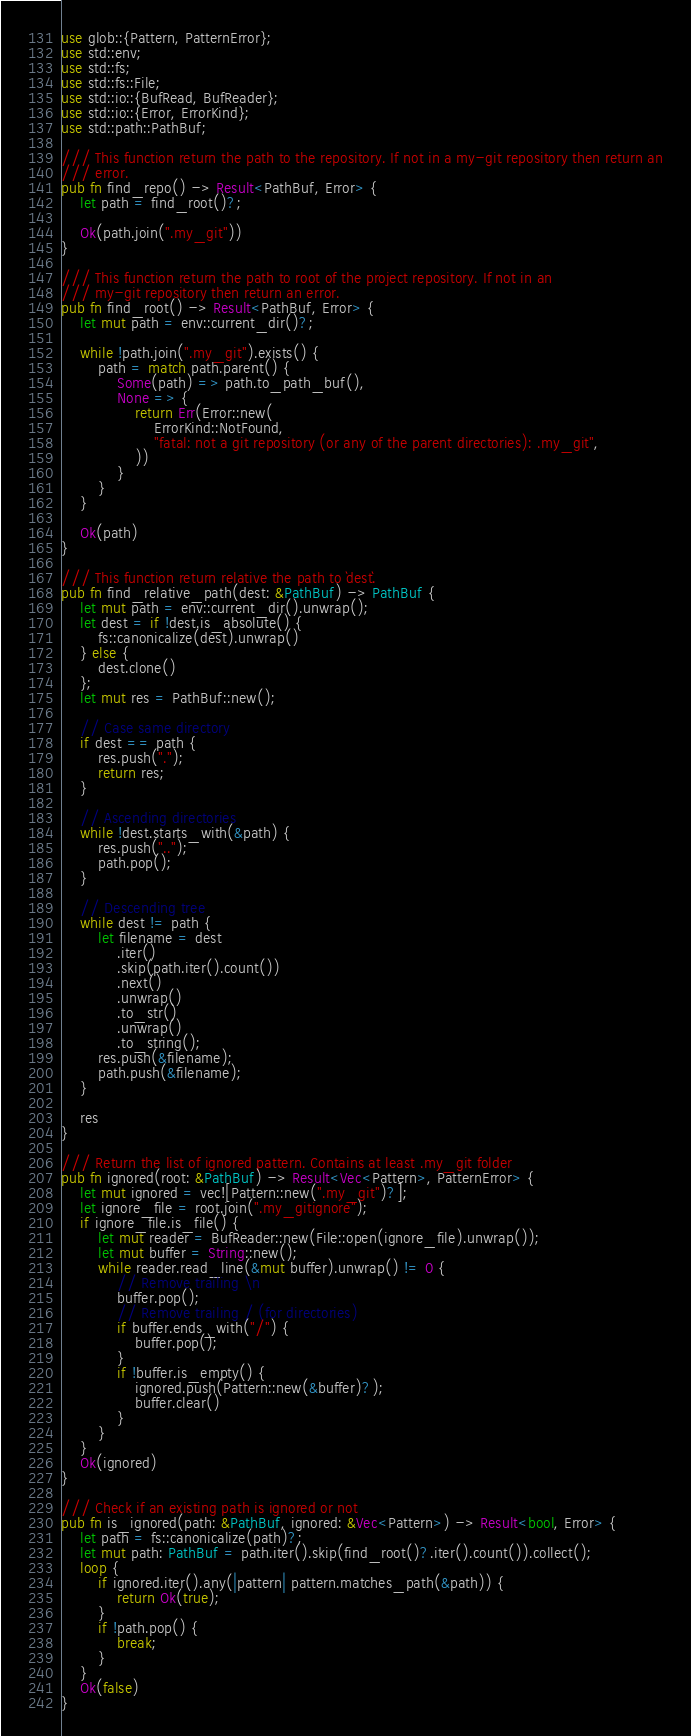Convert code to text. <code><loc_0><loc_0><loc_500><loc_500><_Rust_>use glob::{Pattern, PatternError};
use std::env;
use std::fs;
use std::fs::File;
use std::io::{BufRead, BufReader};
use std::io::{Error, ErrorKind};
use std::path::PathBuf;

/// This function return the path to the repository. If not in a my-git repository then return an
/// error.
pub fn find_repo() -> Result<PathBuf, Error> {
    let path = find_root()?;

    Ok(path.join(".my_git"))
}

/// This function return the path to root of the project repository. If not in an
/// my-git repository then return an error.
pub fn find_root() -> Result<PathBuf, Error> {
    let mut path = env::current_dir()?;

    while !path.join(".my_git").exists() {
        path = match path.parent() {
            Some(path) => path.to_path_buf(),
            None => {
                return Err(Error::new(
                    ErrorKind::NotFound,
                    "fatal: not a git repository (or any of the parent directories): .my_git",
                ))
            }
        }
    }

    Ok(path)
}

/// This function return relative the path to `dest`.
pub fn find_relative_path(dest: &PathBuf) -> PathBuf {
    let mut path = env::current_dir().unwrap();
    let dest = if !dest.is_absolute() {
        fs::canonicalize(dest).unwrap()
    } else {
        dest.clone()
    };
    let mut res = PathBuf::new();

    // Case same directory
    if dest == path {
        res.push(".");
        return res;
    }

    // Ascending directories
    while !dest.starts_with(&path) {
        res.push("..");
        path.pop();
    }

    // Descending tree
    while dest != path {
        let filename = dest
            .iter()
            .skip(path.iter().count())
            .next()
            .unwrap()
            .to_str()
            .unwrap()
            .to_string();
        res.push(&filename);
        path.push(&filename);
    }

    res
}

/// Return the list of ignored pattern. Contains at least .my_git folder
pub fn ignored(root: &PathBuf) -> Result<Vec<Pattern>, PatternError> {
    let mut ignored = vec![Pattern::new(".my_git")?];
    let ignore_file = root.join(".my_gitignore");
    if ignore_file.is_file() {
        let mut reader = BufReader::new(File::open(ignore_file).unwrap());
        let mut buffer = String::new();
        while reader.read_line(&mut buffer).unwrap() != 0 {
            // Remove trailing \n
            buffer.pop();
            // Remove trailing / (for directories)
            if buffer.ends_with("/") {
                buffer.pop();
            }
            if !buffer.is_empty() {
                ignored.push(Pattern::new(&buffer)?);
                buffer.clear()
            }
        }
    }
    Ok(ignored)
}

/// Check if an existing path is ignored or not
pub fn is_ignored(path: &PathBuf, ignored: &Vec<Pattern>) -> Result<bool, Error> {
    let path = fs::canonicalize(path)?;
    let mut path: PathBuf = path.iter().skip(find_root()?.iter().count()).collect();
    loop {
        if ignored.iter().any(|pattern| pattern.matches_path(&path)) {
            return Ok(true);
        }
        if !path.pop() {
            break;
        }
    }
    Ok(false)
}
</code> 